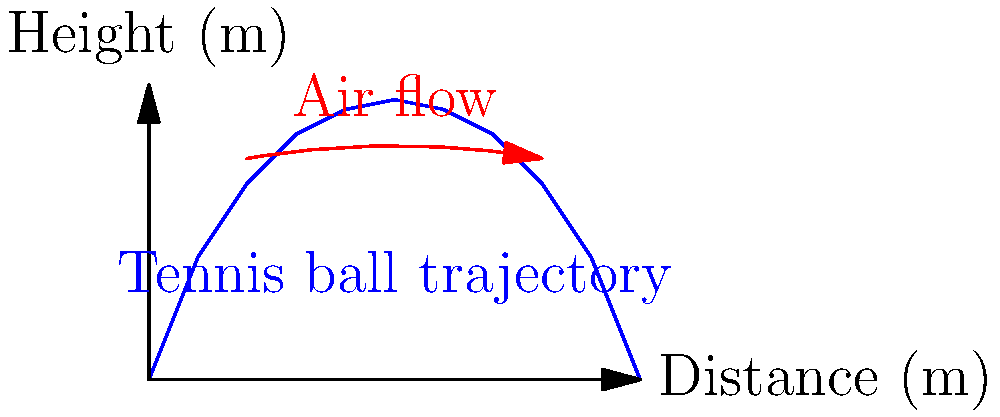In a Davis Cup match, you observe a tennis ball's trajectory as shown in the diagram. What physical principle primarily explains the ball's curved flight path, and how does it affect the ball's motion? To understand the tennis ball's curved flight path, we need to consider the following steps:

1. Initial observation: The ball's trajectory is not a perfect parabola as we might expect from simple projectile motion.

2. Magnus effect: This is the primary principle explaining the curved path. It occurs when a spinning object moves through a fluid (in this case, air).

3. Spin of the ball: In tennis, topspin is commonly applied. The ball rotates forward as it travels.

4. Air interaction: As the ball spins:
   a) The top surface moves in the same direction as the air flow.
   b) The bottom surface moves against the air flow.

5. Pressure difference: This creates a pressure difference:
   a) Lower pressure on top (faster air movement)
   b) Higher pressure on bottom (slower air movement)

6. Resulting force: The pressure difference results in an upward force, perpendicular to the direction of motion.

7. Trajectory alteration: This upward force causes the ball to:
   a) Stay in the air longer than it would without spin
   b) Follow a curved path instead of a simple parabolic arc

8. Practical implications: In tennis, this effect allows players to hit the ball harder while still ensuring it lands within the court boundaries.

The magnitude of this effect depends on factors such as:
- Spin rate of the ball
- Ball's velocity
- Air density
- Ball's surface characteristics

Understanding this principle is crucial for players to control their shots effectively, especially in varying conditions often encountered in Davis Cup matches across different countries.
Answer: Magnus effect 